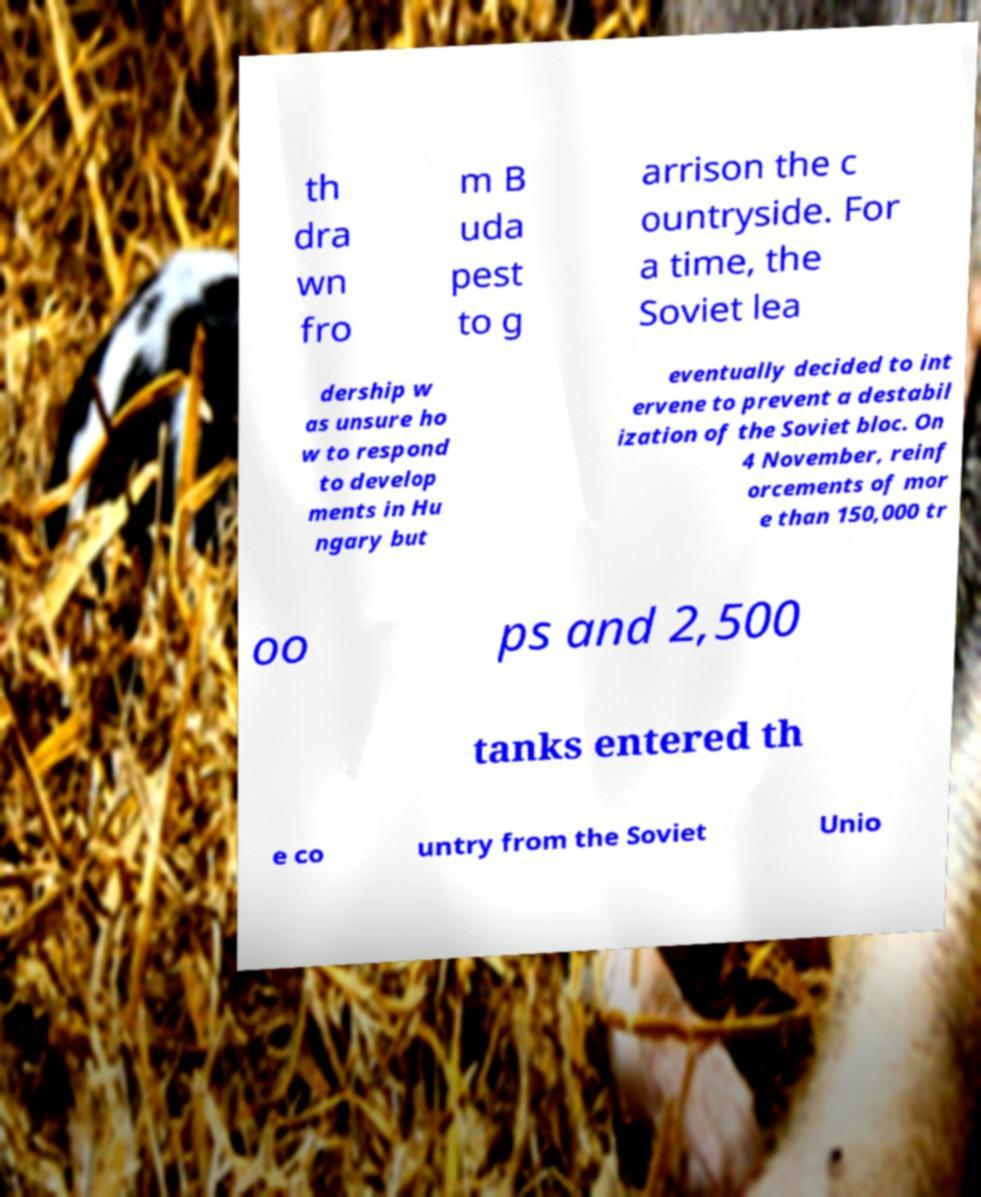For documentation purposes, I need the text within this image transcribed. Could you provide that? th dra wn fro m B uda pest to g arrison the c ountryside. For a time, the Soviet lea dership w as unsure ho w to respond to develop ments in Hu ngary but eventually decided to int ervene to prevent a destabil ization of the Soviet bloc. On 4 November, reinf orcements of mor e than 150,000 tr oo ps and 2,500 tanks entered th e co untry from the Soviet Unio 